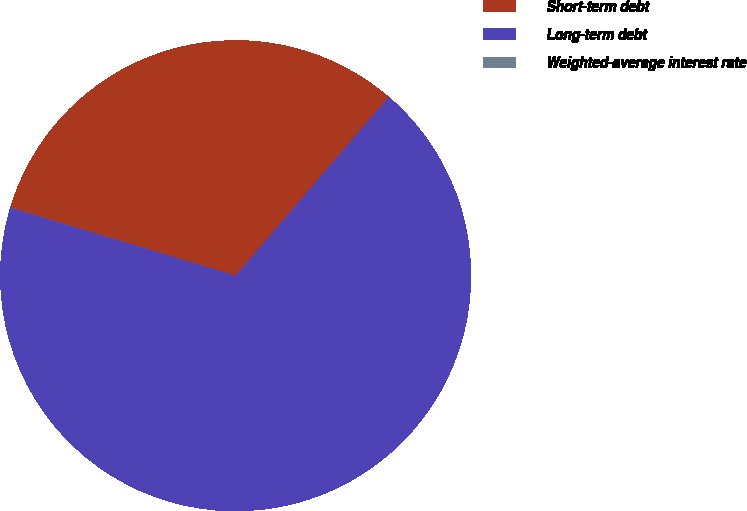Convert chart. <chart><loc_0><loc_0><loc_500><loc_500><pie_chart><fcel>Short-term debt<fcel>Long-term debt<fcel>Weighted-average interest rate<nl><fcel>31.59%<fcel>68.4%<fcel>0.01%<nl></chart> 